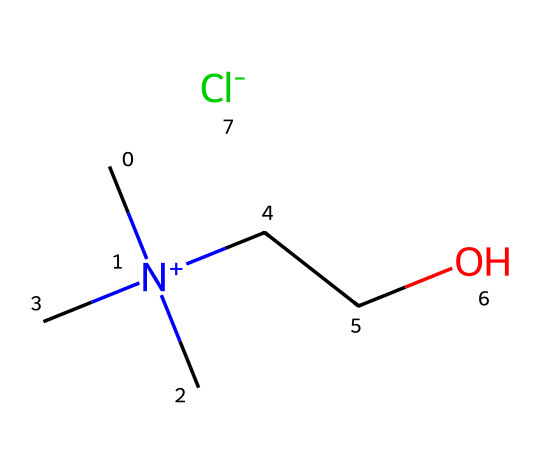What is the general classification of this chemical? This chemical contains a quaternary ammonium cation and is paired with a chloride anion, placing it in the category of ionic liquids.
Answer: ionic liquid How many carbon atoms are present in this chemical? The SMILES representation shows four carbon atoms (indicated by 'C'), thus the count of carbon atoms is four.
Answer: four What type of ion is represented by [Cl-]? The portion [Cl-] indicates a chloride ion, which is a negatively charged ion known as an anion.
Answer: anion How many nitrogen atoms are present in this chemical? The structure includes one nitrogen atom (represented by 'N'), so the total count of nitrogen atoms is one.
Answer: one What functional group is indicated by 'CCO' in this structure? The 'CCO' sequence indicates the presence of an alcohol functional group, specifically a linear alcohol, due to the 'CO' end.
Answer: alcohol Which part of the chemical contributes to its ionic properties? The quaternary ammonium structure (C[N+](C)(C)CC) contains a positively charged nitrogen atom, contributing to the ionic nature of the liquid.
Answer: quaternary ammonium 